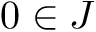<formula> <loc_0><loc_0><loc_500><loc_500>0 \in J</formula> 